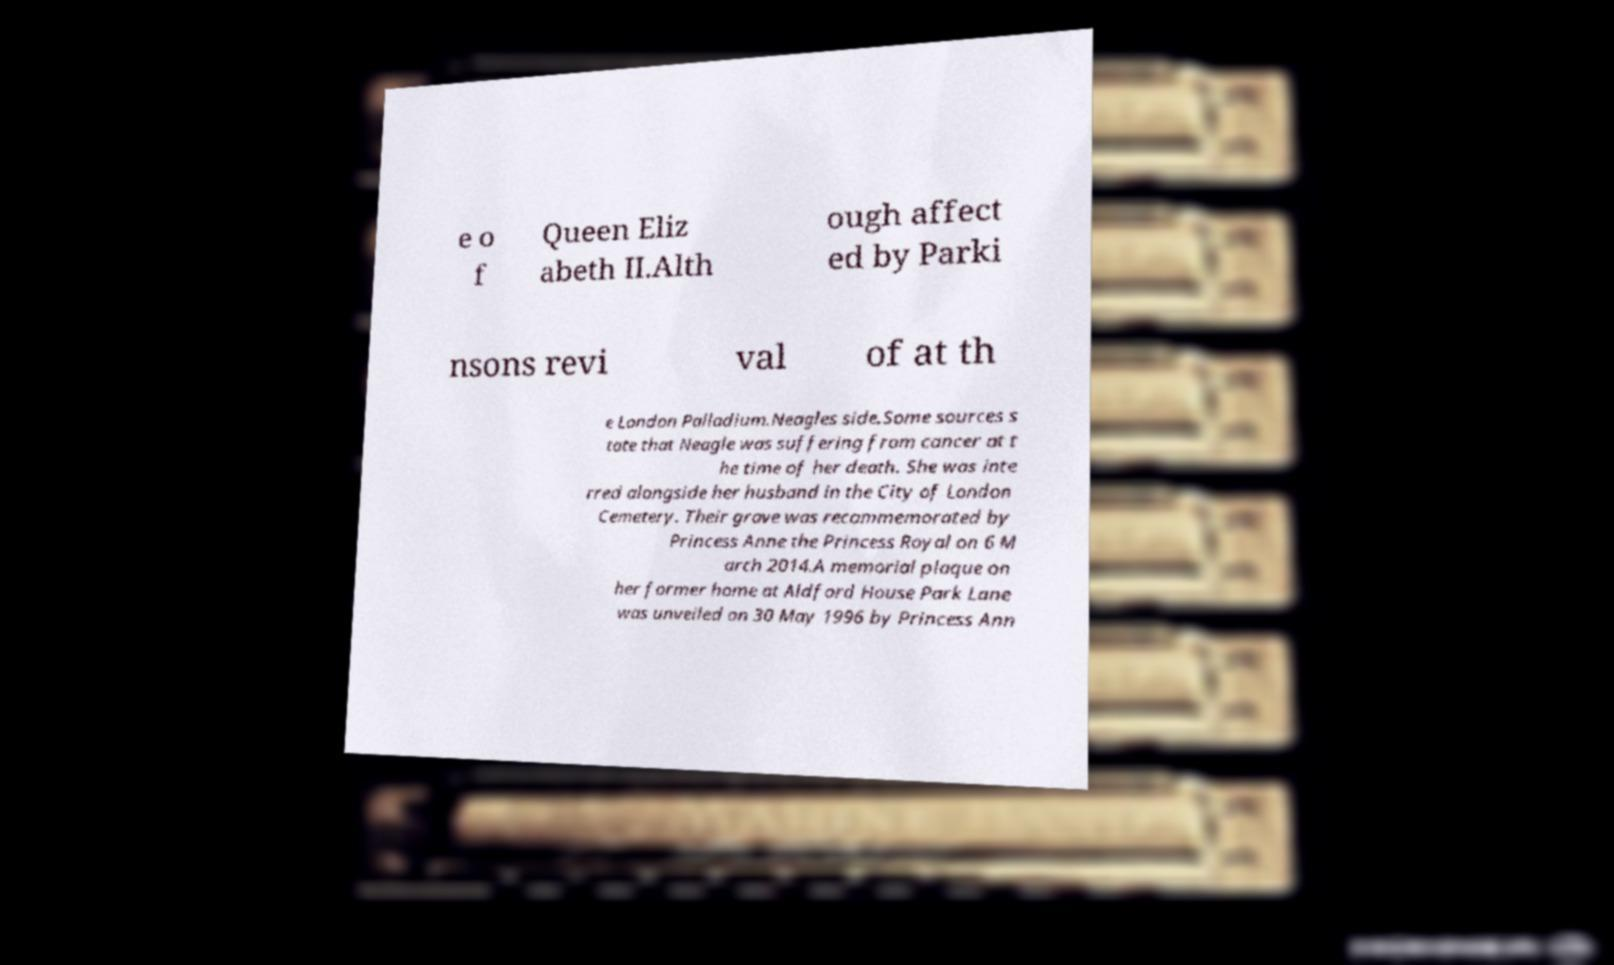For documentation purposes, I need the text within this image transcribed. Could you provide that? e o f Queen Eliz abeth II.Alth ough affect ed by Parki nsons revi val of at th e London Palladium.Neagles side.Some sources s tate that Neagle was suffering from cancer at t he time of her death. She was inte rred alongside her husband in the City of London Cemetery. Their grave was recommemorated by Princess Anne the Princess Royal on 6 M arch 2014.A memorial plaque on her former home at Aldford House Park Lane was unveiled on 30 May 1996 by Princess Ann 